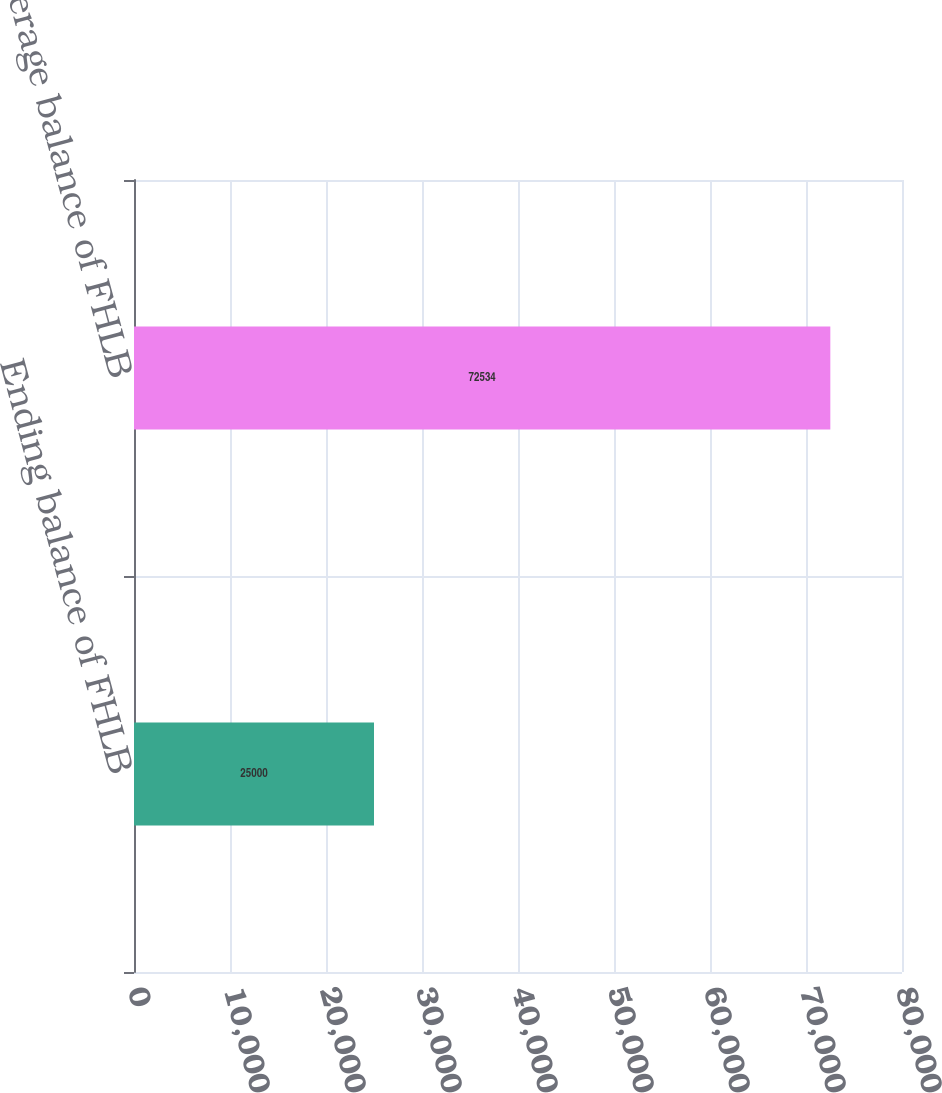Convert chart. <chart><loc_0><loc_0><loc_500><loc_500><bar_chart><fcel>Ending balance of FHLB<fcel>Average balance of FHLB<nl><fcel>25000<fcel>72534<nl></chart> 